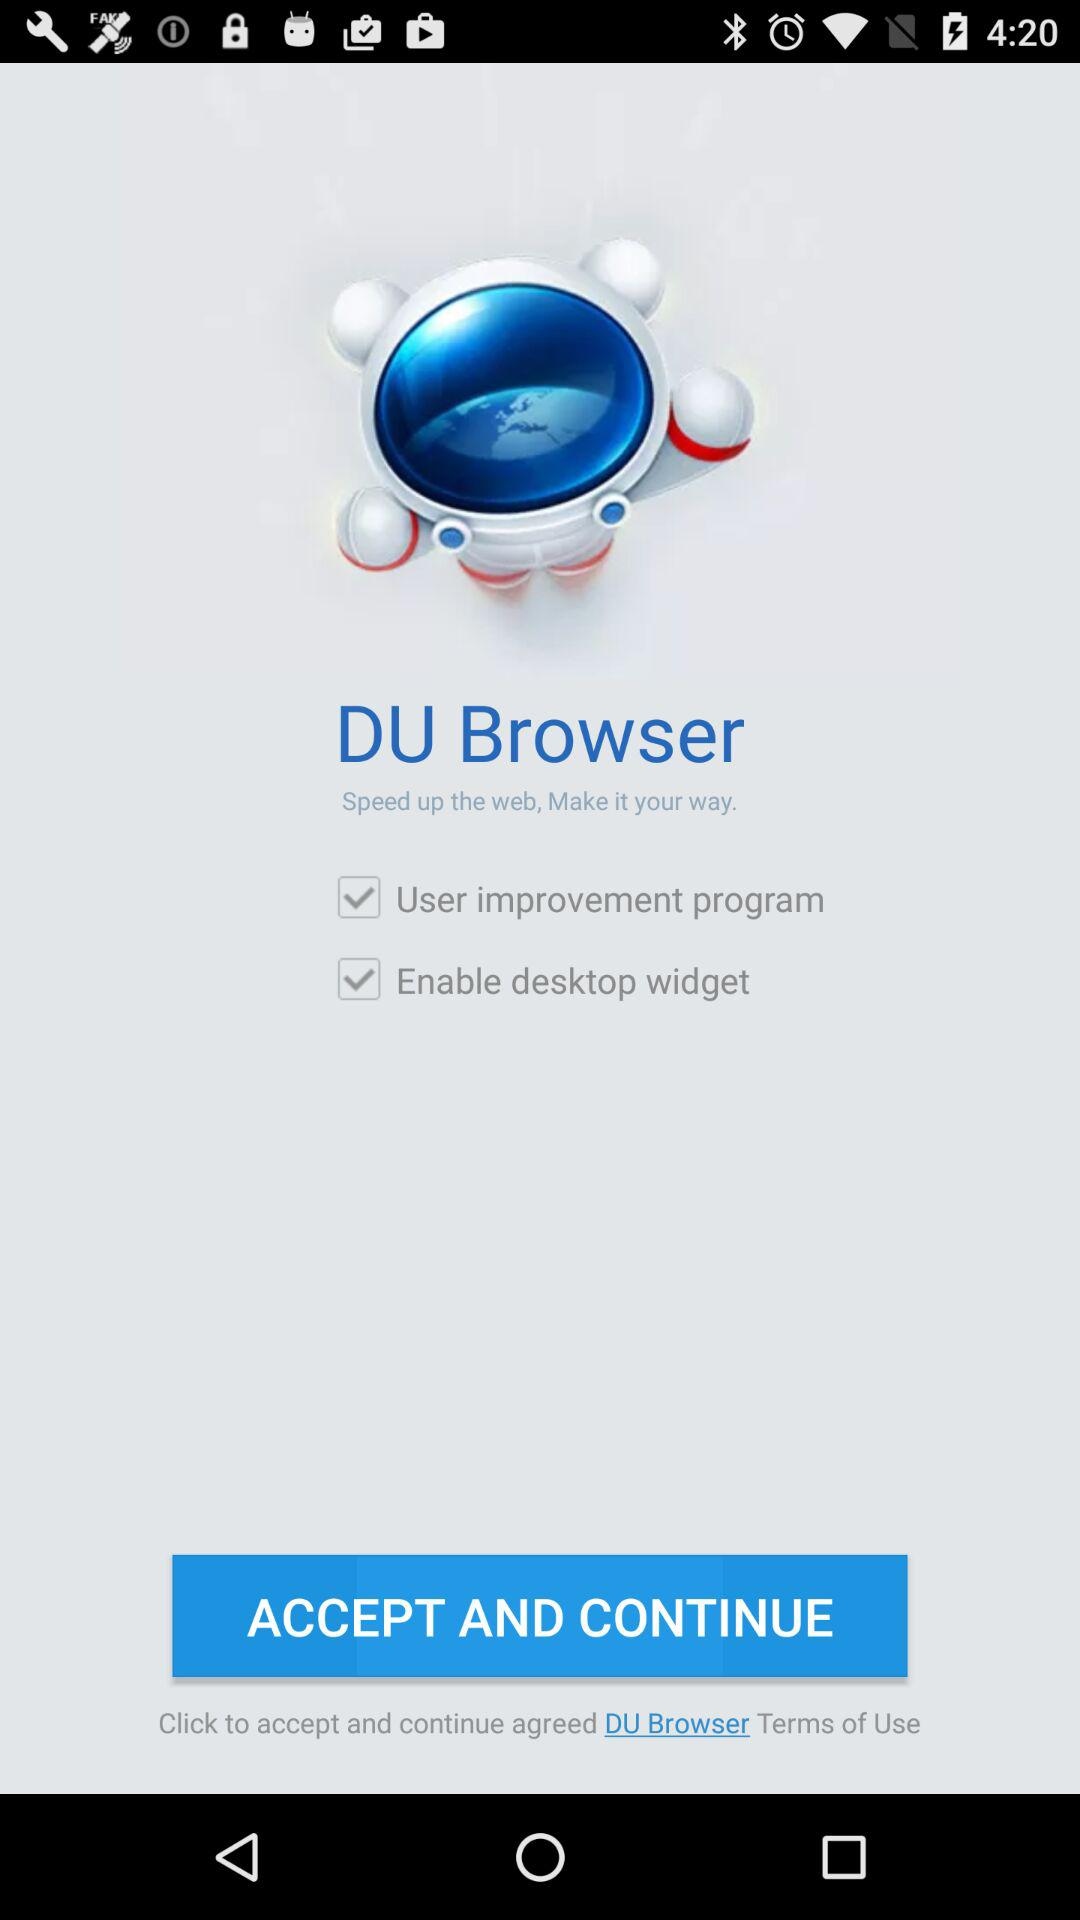What is the status of the "Enable desktop widget"? The status is "on". 